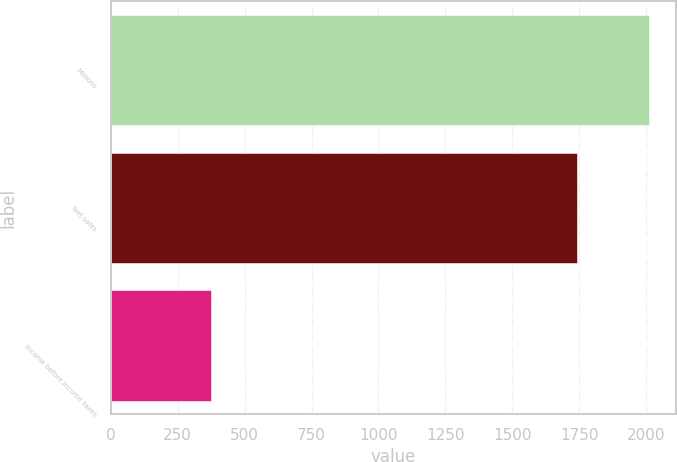Convert chart to OTSL. <chart><loc_0><loc_0><loc_500><loc_500><bar_chart><fcel>Millions<fcel>Net sales<fcel>Income before income taxes<nl><fcel>2011<fcel>1741<fcel>376<nl></chart> 